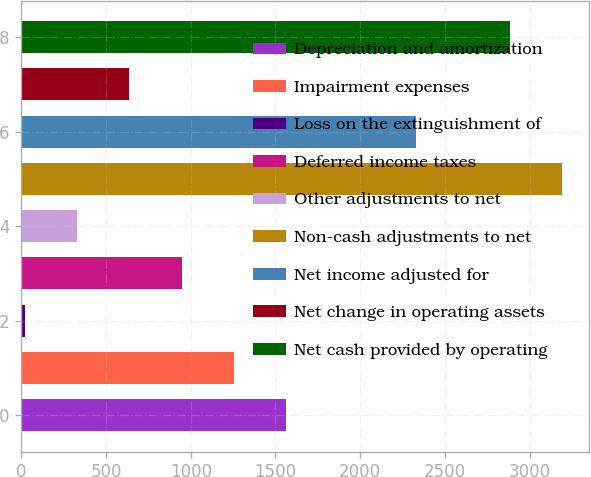Convert chart. <chart><loc_0><loc_0><loc_500><loc_500><bar_chart><fcel>Depreciation and amortization<fcel>Impairment expenses<fcel>Loss on the extinguishment of<fcel>Deferred income taxes<fcel>Other adjustments to net<fcel>Non-cash adjustments to net<fcel>Net income adjusted for<fcel>Net change in operating assets<fcel>Net cash provided by operating<nl><fcel>1564.5<fcel>1255.6<fcel>20<fcel>946.7<fcel>328.9<fcel>3192.9<fcel>2332<fcel>637.8<fcel>2884<nl></chart> 